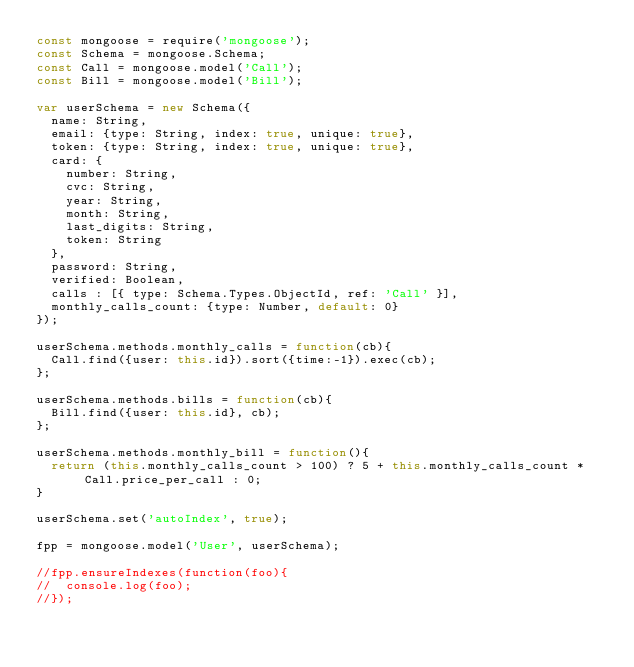<code> <loc_0><loc_0><loc_500><loc_500><_JavaScript_>const mongoose = require('mongoose');
const Schema = mongoose.Schema;
const Call = mongoose.model('Call');
const Bill = mongoose.model('Bill');

var userSchema = new Schema({
  name: String,
  email: {type: String, index: true, unique: true},
  token: {type: String, index: true, unique: true},
  card: {
    number: String,
    cvc: String,
    year: String,
    month: String,
    last_digits: String,
    token: String
  },
  password: String,
  verified: Boolean,
  calls : [{ type: Schema.Types.ObjectId, ref: 'Call' }],
  monthly_calls_count: {type: Number, default: 0}
});

userSchema.methods.monthly_calls = function(cb){
  Call.find({user: this.id}).sort({time:-1}).exec(cb);
};

userSchema.methods.bills = function(cb){
  Bill.find({user: this.id}, cb);
};

userSchema.methods.monthly_bill = function(){
  return (this.monthly_calls_count > 100) ? 5 + this.monthly_calls_count * Call.price_per_call : 0;
}

userSchema.set('autoIndex', true);

fpp = mongoose.model('User', userSchema);

//fpp.ensureIndexes(function(foo){
//  console.log(foo);
//});</code> 